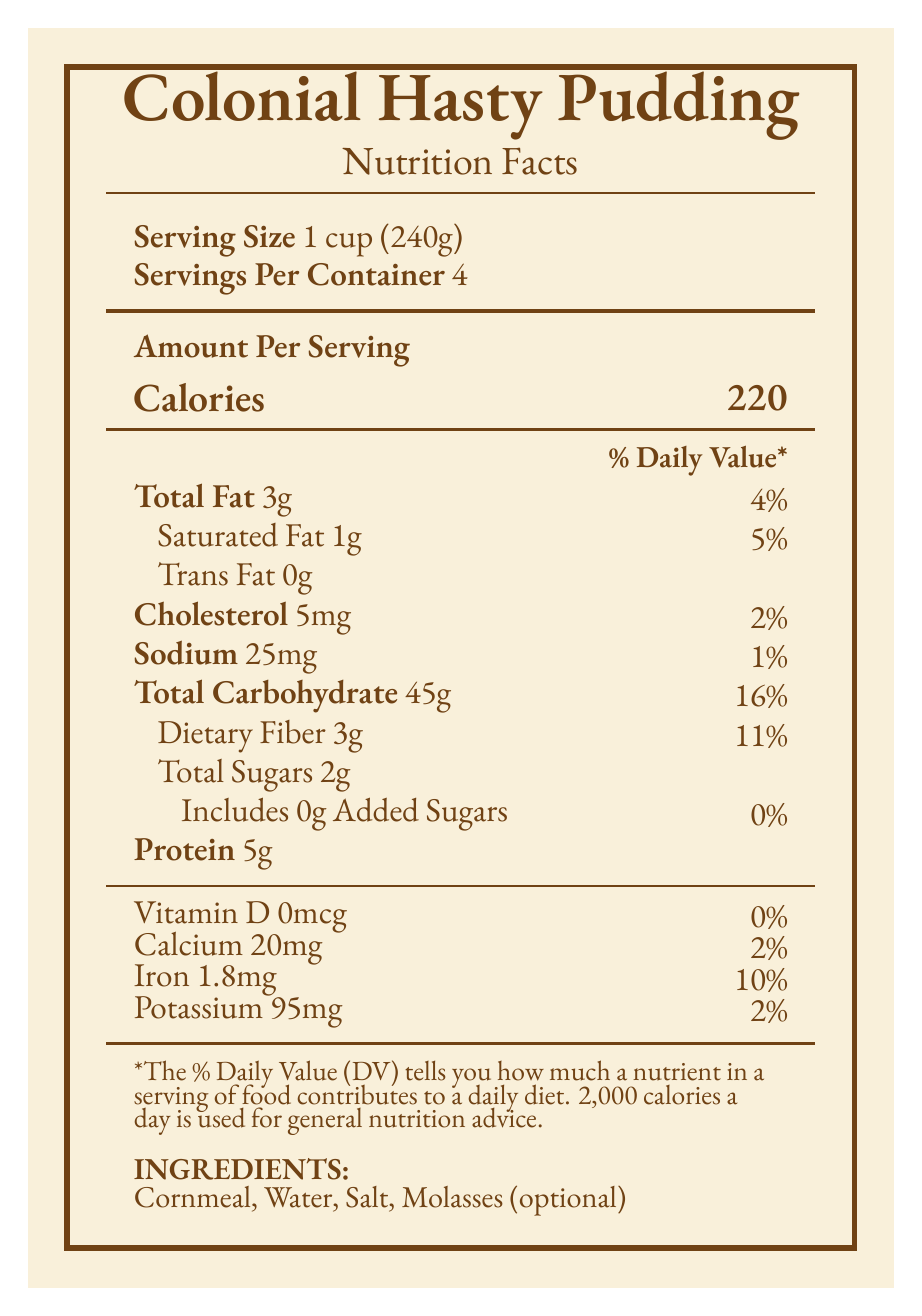What is the serving size for Colonial Hasty Pudding? The document states the serving size as "1 cup (240g)" under the "Serving Size" section.
Answer: 1 cup (240g) How many servings are in one container of Colonial Hasty Pudding? The document states "Servings Per Container" as 4.
Answer: 4 What is the total carbohydrate content per serving of Colonial Hasty Pudding? The document lists "Total Carbohydrate" as 45g per serving.
Answer: 45g What is the amount of dietary fiber in each serving? The document lists "Dietary Fiber" as 3g per serving.
Answer: 3g Which ingredient was commonly added during the 18th century due to colonial trade? Historical notes indicate that molasses became a common sweetener after the Triangle Trade in the 18th century.
Answer: Molasses What is the main source of protein in Colonial Hasty Pudding? A. Cornmeal B. Water C. Salt The main source of protein is listed in the ingredients, and the protein content can be attributed to cornmeal.
Answer: A How has the fat content of Colonial Hasty Pudding changed over time? A. Increased in the 19th century B. Decreased in the 19th century C. Remained the same The nutritional changes note that the fat content increased with the inclusion of milk and butter in the 19th century.
Answer: A How much iron is in a serving of Colonial Hasty Pudding? The document states that each serving contains 1.8mg of iron.
Answer: 1.8mg Does Colonial Hasty Pudding contain any trans fat? The document lists Trans Fat as 0g per serving.
Answer: No Does the document state the specific percentage of daily value for potassium? It lists Potassium as 2%.
Answer: Yes Summarize the nutritional content and historical context of Colonial Hasty Pudding as presented in the document. The summary captures the main nutritional figures and key historical shifts in ingredients and their cultural impacts as detailed in the document.
Answer: Colonial Hasty Pudding has a serving size of 1 cup (240g) with 220 calories per serving. It contains 3g of total fat, 1g of saturated fat, 0g of trans fat, 5mg of cholesterol, 25mg of sodium, 45g of carbohydrates, 3g of dietary fiber, 2g of total sugars, and 5g of protein. It also includes small amounts of Vitamin D, calcium, iron, and potassium. The ingredients include cornmeal, water, salt, and optional molasses. Historical notes indicate the original recipe dates back to 17th century New England, with molasses becoming common in the 18th century, and milk and butter added in the 19th century to increase fat content. Cornmeal replaced traditional English wheat due to availability in colonial America. Over time, the nutritional content shifted accordingly, reflecting the period's available ingredients and culinary practices. What does the footnote about daily values explain? The footnote states: "*The % Daily Value (DV) tells you how much a nutrient in a serving of food contributes to a daily diet. 2,000 calories a day is used for general nutrition advice."
Answer: It explains that the % Daily Value indicates how much a nutrient in a serving of food contributes to a daily diet, based on a 2,000 calorie daily intake used for general nutrition advice. Are there added sugars in Colonial Hasty Pudding? The document states that it includes 0g of added sugars.
Answer: No What was the original grain used in the English version of this dish before it was replaced with cornmeal in colonial America? The document provides details about the use of cornmeal in colonial America but does not specify the original grain used in the English version directly. Therefore, the answer is not explicitly provided in the document.
Answer: Not enough information 